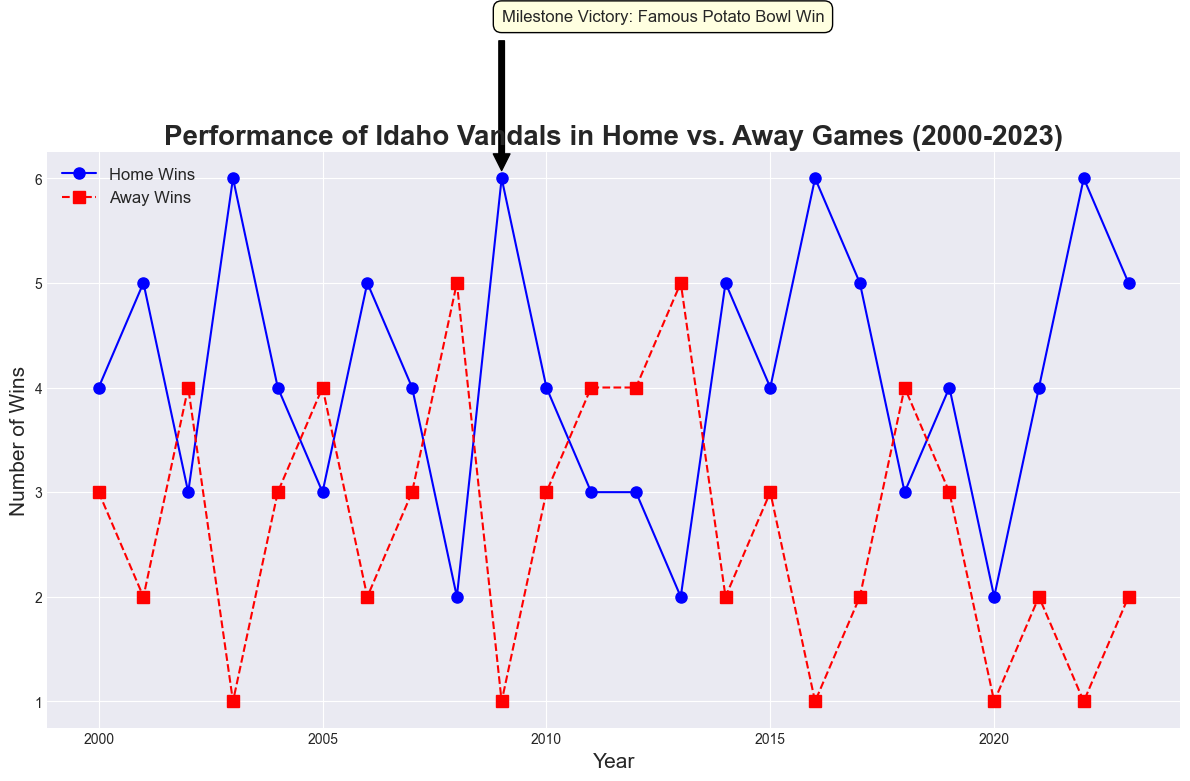What's the highest number of home wins recorded? The highest point on the blue line represents the maximum number of home wins. The blue line peaks at 6 wins multiple times (2003, 2009, 2016, and 2022).
Answer: 6 In which year did the Idaho Vandals achieve a milestone victory? Look for the annotated point on the line chart, which is marked by an annotation. The annotation indicates the milestone victory in 2009.
Answer: 2009 What is the range of away wins from 2000 to 2023? Identify the highest and lowest points on the red dashed line. The highest number of away wins is 5 (recorded several years like 2002, 2008, 2013), and the lowest is 1 (recorded in 2020). The range is 5 - 1 = 4.
Answer: 4 Which year had the same number of home and away wins? Look for years where the blue and red lines intersect or have equal y-values. In 2000, both Home Wins and Away Wins were 3.
Answer: 2000 How many times did home wins equal 4 in the given period? Count the number of points on the blue line where the y-value (Home Wins) is 4. These are in the years 2000, 2004, 2007, 2010, 2015, 2019, and 2021, which totals to 7 times.
Answer: 7 In which year did the Idaho Vandals win the Famous Potato Bowl? Refer to the annotation text which specifically highlights the Famous Potato Bowl Win. This occurred in 2009.
Answer: 2009 By how much did home wins exceed away wins in 2003? Identify the values for home wins and away wins in 2003 from the chart. Home Wins were 6 and Away Wins were 1. The difference is 6 - 1 = 5.
Answer: 5 What was the average number of away wins from 2000 to 2023? Sum all the away wins and divide by the number of years. The total number of away wins is 66 over 24 years, giving an average of 66 / 24 ≈ 2.75.
Answer: 2.75 How does the number of home wins in 2022 compare to the number of home wins in 2021? From the chart, the number of home wins in 2022 is 6, and in 2021, it is 4. So, 2022 had more home wins by 6 - 4 = 2.
Answer: 2 more Which year had the highest combined total of home and away wins? Calculate the sum of home and away wins for each year and determine which is the highest. The highest combined total is 8, which occurs in 2009 (6 Home Wins + 2 Away Wins) and in 2016 (6 Home Wins + 2 Away Wins).
Answer: 2009, 2016 